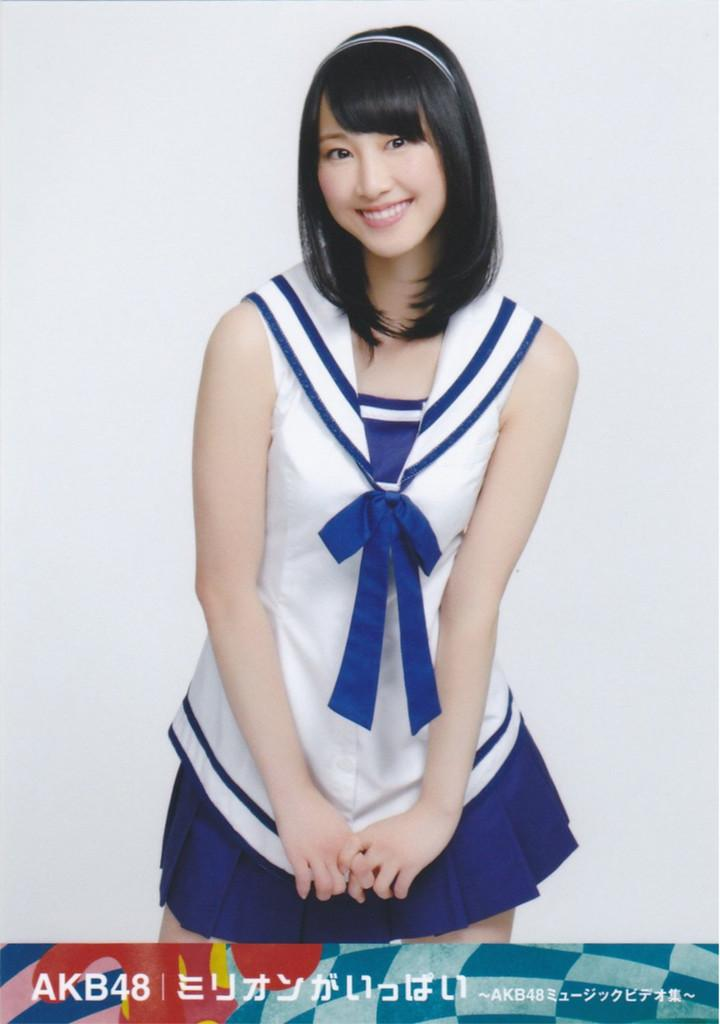<image>
Relay a brief, clear account of the picture shown. A pretty young woman stands over a colorful banner with the number and letter combo of AKB48 on it. 